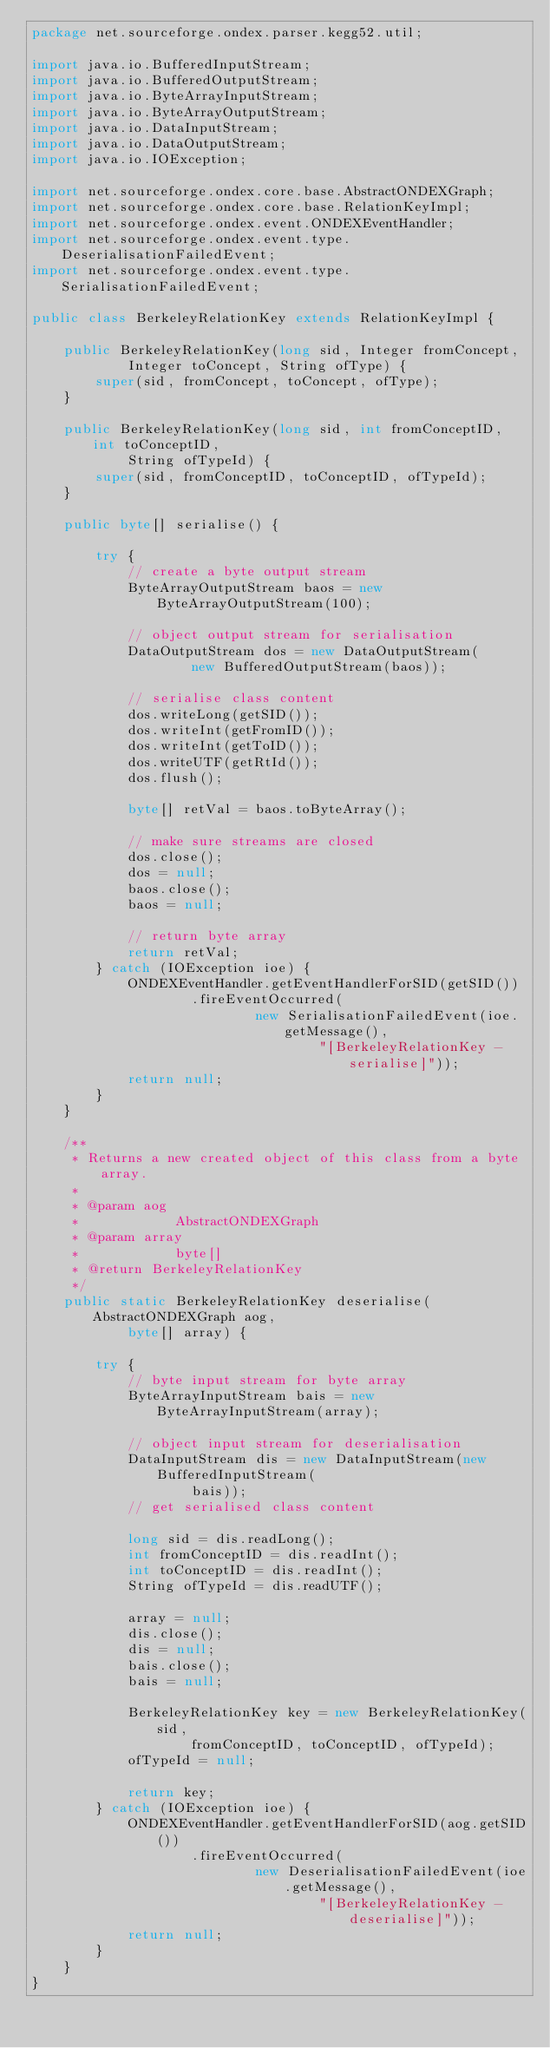<code> <loc_0><loc_0><loc_500><loc_500><_Java_>package net.sourceforge.ondex.parser.kegg52.util;

import java.io.BufferedInputStream;
import java.io.BufferedOutputStream;
import java.io.ByteArrayInputStream;
import java.io.ByteArrayOutputStream;
import java.io.DataInputStream;
import java.io.DataOutputStream;
import java.io.IOException;

import net.sourceforge.ondex.core.base.AbstractONDEXGraph;
import net.sourceforge.ondex.core.base.RelationKeyImpl;
import net.sourceforge.ondex.event.ONDEXEventHandler;
import net.sourceforge.ondex.event.type.DeserialisationFailedEvent;
import net.sourceforge.ondex.event.type.SerialisationFailedEvent;

public class BerkeleyRelationKey extends RelationKeyImpl {

	public BerkeleyRelationKey(long sid, Integer fromConcept,
			Integer toConcept, String ofType) {
		super(sid, fromConcept, toConcept, ofType);
	}

	public BerkeleyRelationKey(long sid, int fromConceptID, int toConceptID,
			String ofTypeId) {
		super(sid, fromConceptID, toConceptID, ofTypeId);
	}

	public byte[] serialise() {

		try {
			// create a byte output stream
			ByteArrayOutputStream baos = new ByteArrayOutputStream(100);

			// object output stream for serialisation
			DataOutputStream dos = new DataOutputStream(
					new BufferedOutputStream(baos));

			// serialise class content
			dos.writeLong(getSID());
			dos.writeInt(getFromID());
			dos.writeInt(getToID());
			dos.writeUTF(getRtId());
			dos.flush();

			byte[] retVal = baos.toByteArray();

			// make sure streams are closed
			dos.close();
			dos = null;
			baos.close();
			baos = null;

			// return byte array
			return retVal;
		} catch (IOException ioe) {
			ONDEXEventHandler.getEventHandlerForSID(getSID())
					.fireEventOccurred(
							new SerialisationFailedEvent(ioe.getMessage(),
									"[BerkeleyRelationKey - serialise]"));
			return null;
		}
	}

	/**
	 * Returns a new created object of this class from a byte array.
	 * 
	 * @param aog
	 *            AbstractONDEXGraph
	 * @param array
	 *            byte[]
	 * @return BerkeleyRelationKey
	 */
	public static BerkeleyRelationKey deserialise(AbstractONDEXGraph aog,
			byte[] array) {

		try {
			// byte input stream for byte array
			ByteArrayInputStream bais = new ByteArrayInputStream(array);

			// object input stream for deserialisation
			DataInputStream dis = new DataInputStream(new BufferedInputStream(
					bais));
			// get serialised class content

			long sid = dis.readLong();
			int fromConceptID = dis.readInt();
			int toConceptID = dis.readInt();
			String ofTypeId = dis.readUTF();

			array = null;
			dis.close();
			dis = null;
			bais.close();
			bais = null;

			BerkeleyRelationKey key = new BerkeleyRelationKey(sid,
					fromConceptID, toConceptID, ofTypeId);
			ofTypeId = null;

			return key;
		} catch (IOException ioe) {
			ONDEXEventHandler.getEventHandlerForSID(aog.getSID())
					.fireEventOccurred(
							new DeserialisationFailedEvent(ioe.getMessage(),
									"[BerkeleyRelationKey - deserialise]"));
			return null;
		}
	}
}
</code> 